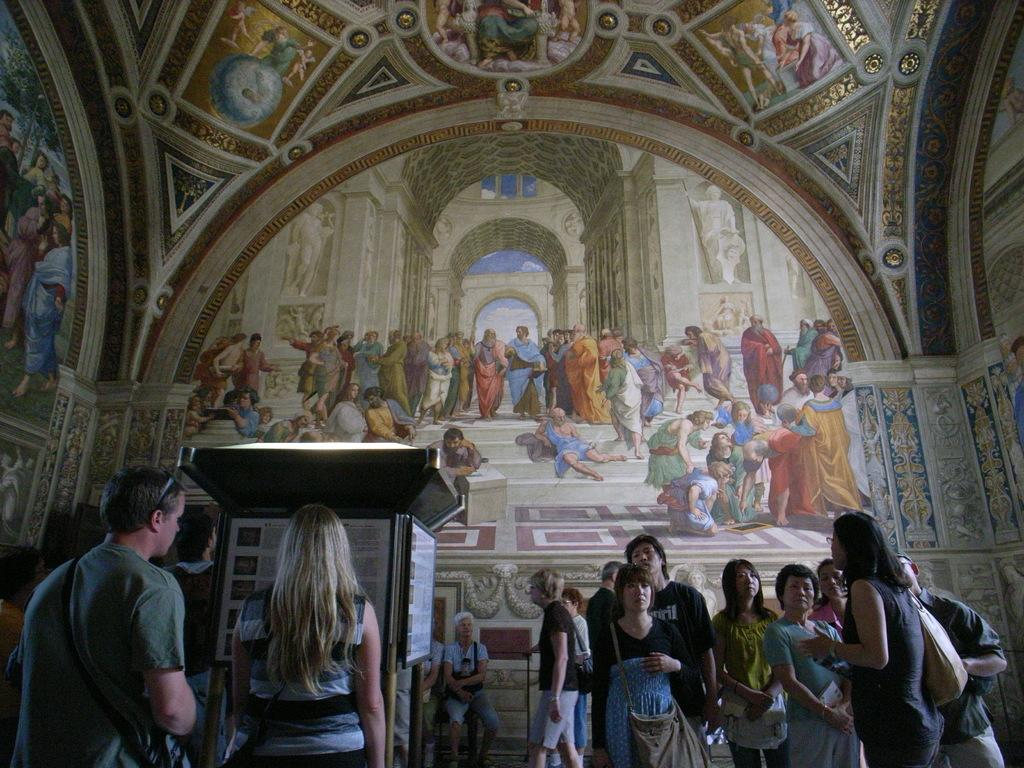What type of location is depicted in the image? The image is taken inside a church. What are the people in the image doing? There are people standing and sitting in the image. Can you describe the object with text boards in the image? The object with text boards is likely a sign or notice board. What type of kettle is being used to test the new theory in the image? There is no kettle or reference to a theory in the image; it depicts a church with people standing and sitting. 